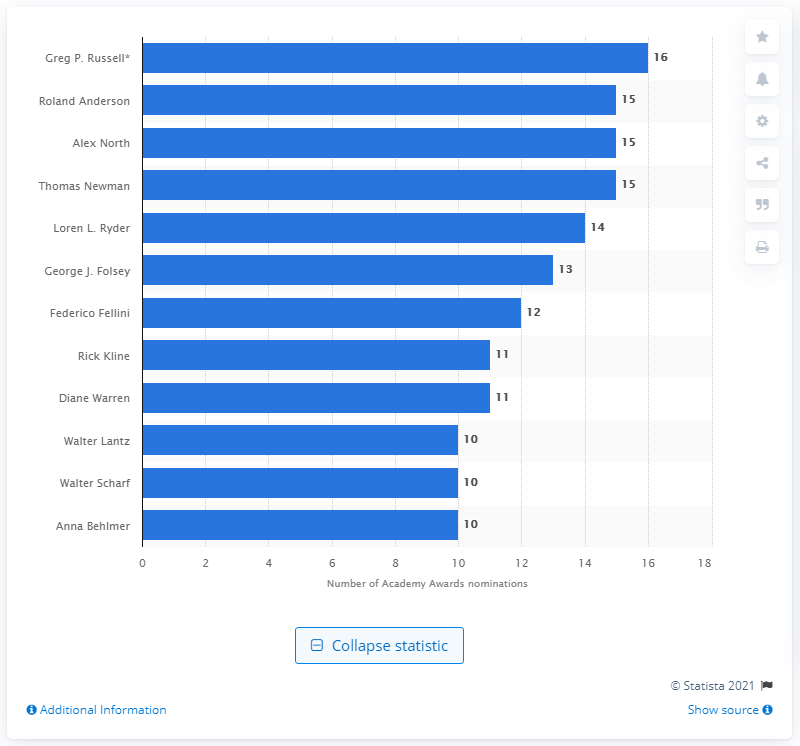Specify some key components in this picture. Diane Warren was nominated for her song "I'll Fight" for the tenth time. 